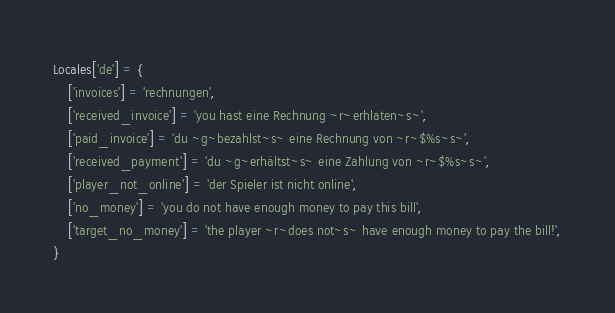Convert code to text. <code><loc_0><loc_0><loc_500><loc_500><_Lua_>Locales['de'] = {
	['invoices'] = 'rechnungen',
	['received_invoice'] = 'you hast eine Rechnung ~r~erhlaten~s~',
	['paid_invoice'] = 'du ~g~bezahlst~s~ eine Rechnung von ~r~$%s~s~',
	['received_payment'] = 'du ~g~erhältst~s~ eine Zahlung von ~r~$%s~s~',
	['player_not_online'] = 'der Spieler ist nicht online',
	['no_money'] = 'you do not have enough money to pay this bill',
	['target_no_money'] = 'the player ~r~does not~s~ have enough money to pay the bill!',
}
</code> 